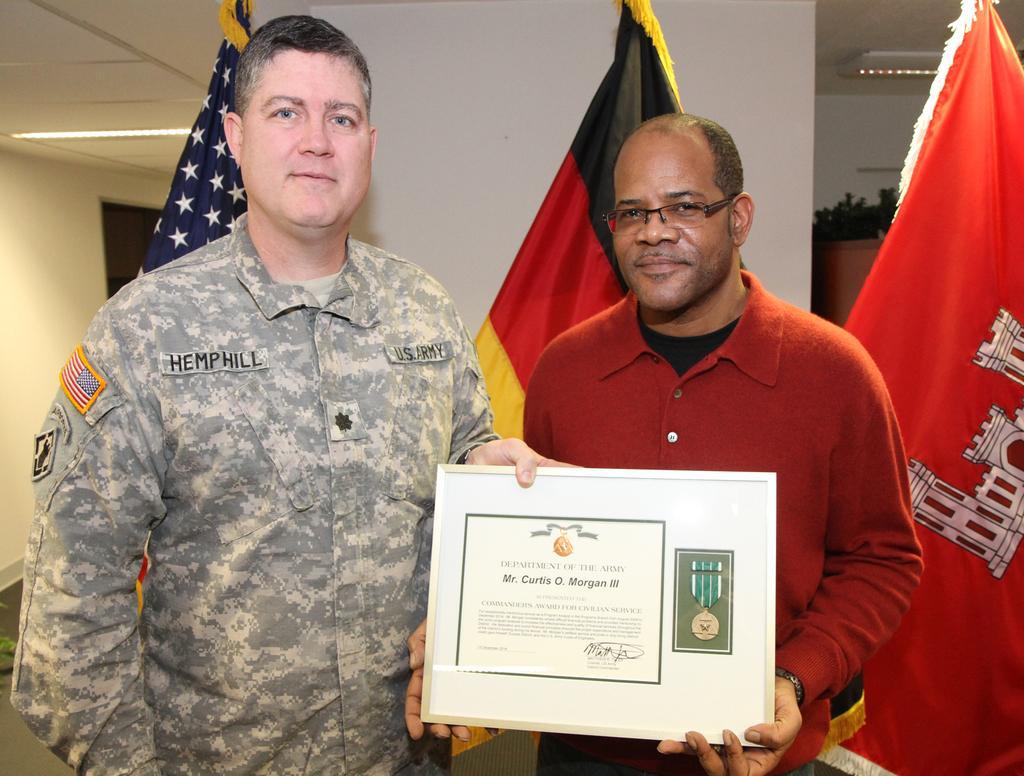Please provide a concise description of this image. In this image there are two men holding a award in their hands, in the background there are three flags and a wall. 